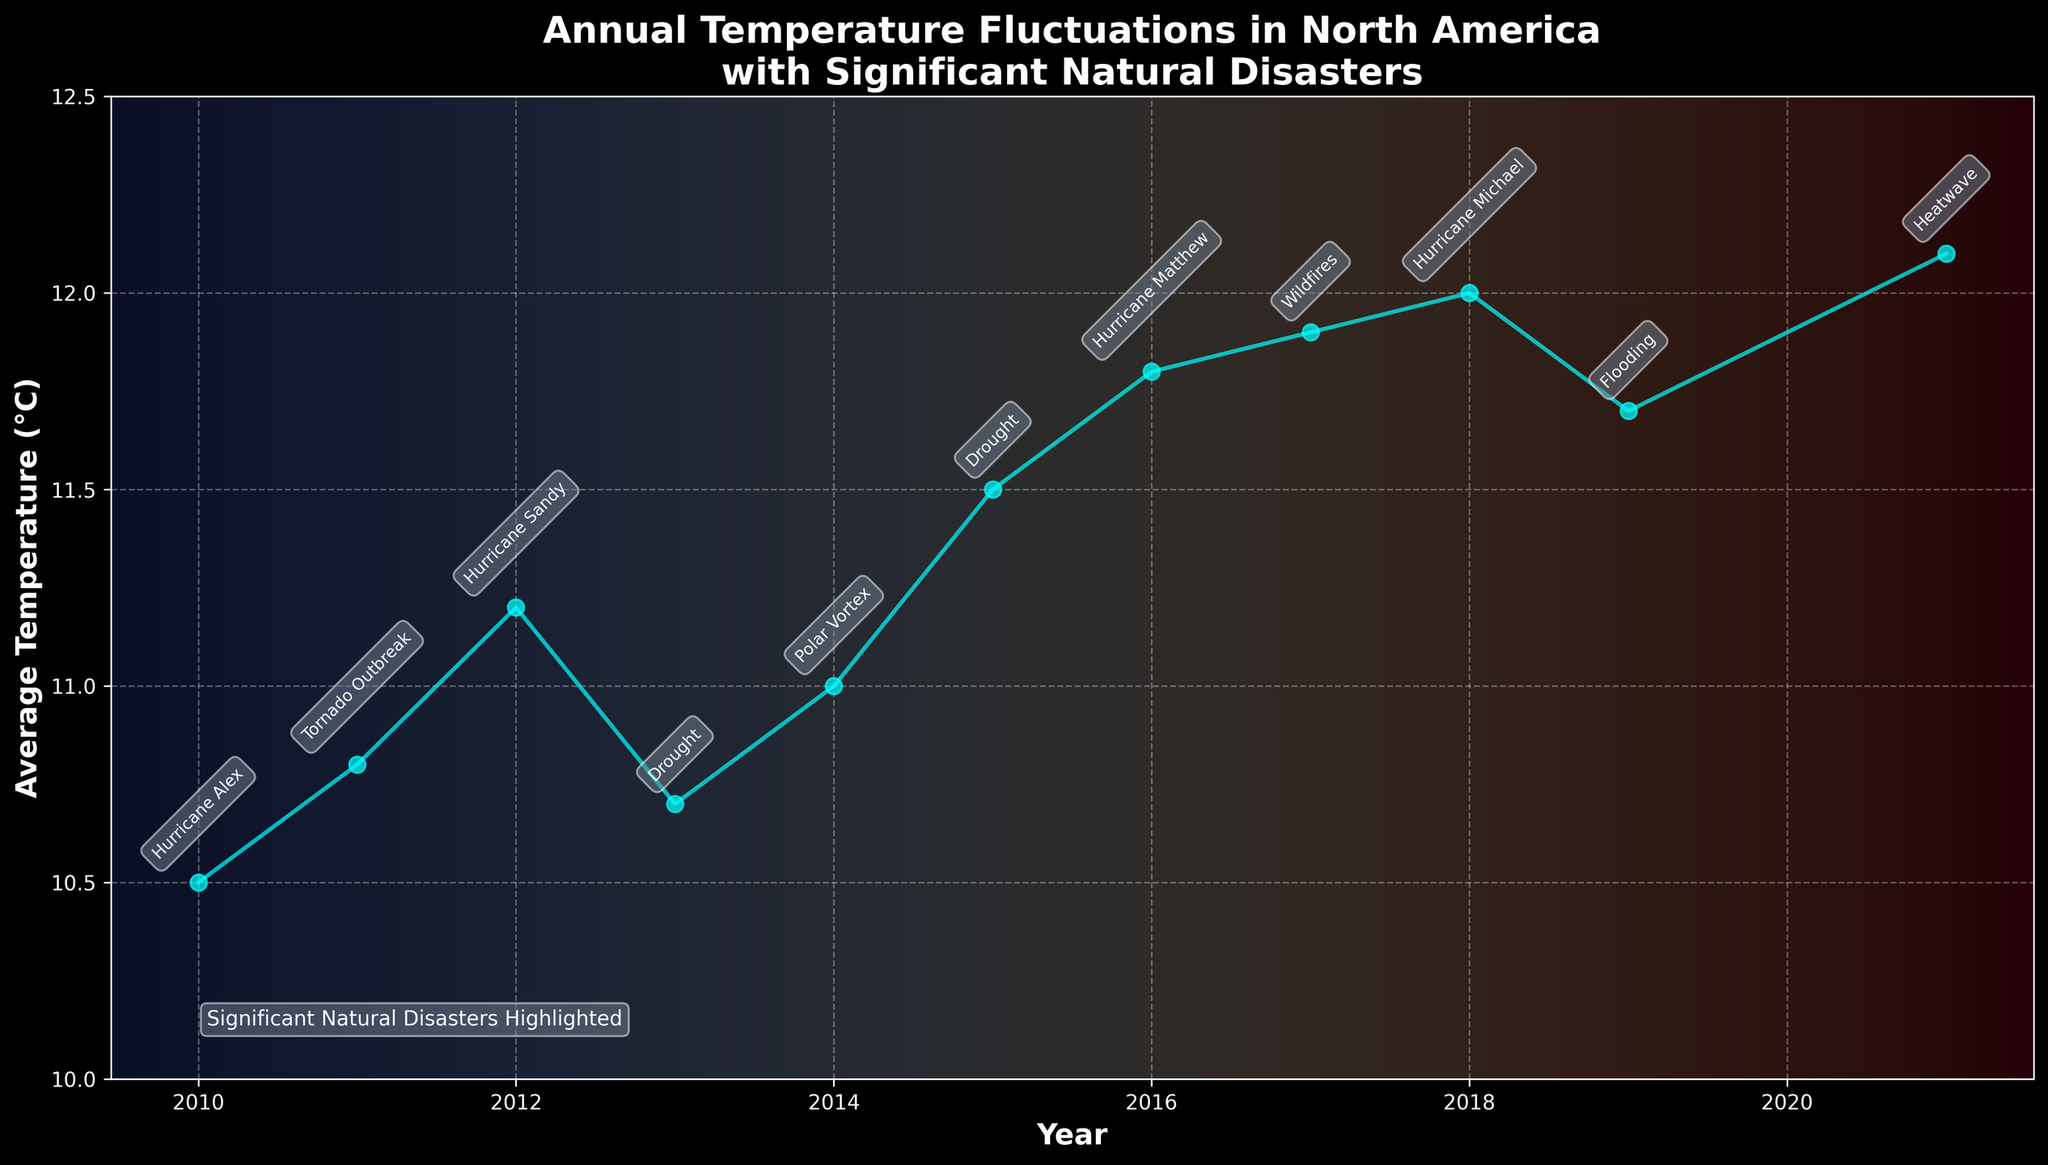What is the title of the plot? The title of the plot is located at the top of the figure and provides an overview of the plot's subject. In this case, the title reads "Annual Temperature Fluctuations in North America\nwith Significant Natural Disasters."
Answer: Annual Temperature Fluctuations in North America\nwith Significant Natural Disasters What is the average temperature in North America in 2017? To determine the average temperature for 2017, locate the data point corresponding to the year 2017 on the x-axis, then read the associated y-axis value, which represents the average temperature.
Answer: 11.9°C Which year shows the highest average temperature? To find the highest average temperature, examine the y-axis values for all data points and find the year that corresponds to the maximum value. The highest data point is at 12.1°C in 2021.
Answer: 2021 What natural disaster is associated with the year 2013? Locate the annotation linked to the year 2013 on the x-axis and read the label of the event connected with it. The plot indicates a "Drought" in 2013.
Answer: Drought How does the average temperature in 2015 compare to 2011? Identify the average temperatures for the years 2015 and 2011. In 2015, the average temperature is 11.5°C, while in 2011, it is 10.8°C. Comparing the two values shows that 2015 is warmer by 0.7°C.
Answer: 0.7°C higher What is the total number of significant natural disasters highlighted in the figure? Count the number of event annotations on the plot. Each annotation corresponds to a natural disaster: Hurricane Alex, Tornado Outbreak, Hurricane Sandy, Drought (twice), Polar Vortex, Hurricane Matthew, Wildfires, Hurricane Michael, Flooding, and Heatwave. This results in 11 significant natural disasters.
Answer: 11 Which event is associated with the lowest average temperature, and what was the temperature? To determine this, locate the lowest point on the plot and read the annotation and the corresponding temperature. The lowest temperature is 10.5°C in 2010, associated with Hurricane Alex.
Answer: Hurricane Alex, 10.5°C What trend is observed in the average temperature from 2010 to 2019? Note the general direction of data points from 2010 to 2019. Despite some fluctuations, the overall trend is an increase in average temperature from 10.5°C in 2010 to 11.7°C in 2019.
Answer: Increasing trend Did the average temperature ever decrease two years in a row between 2010 and 2021? Observe the plot to find consecutive years with decreasing temperatures. From 2018 to 2019, and from 2019 to 2020 (though 2020 data is missing), there is no visible two-year consecutive decrease.
Answer: No What was the temperature difference between the year with Hurricane Sandy (2012) and the year with the Polar Vortex event (2014)? To find the temperature difference, identify the temperatures in 2012 and 2014. The average temperatures are 11.2°C in 2012 and 11.0°C in 2014. The difference is 11.2 - 11.0 = 0.2°C.
Answer: 0.2°C 